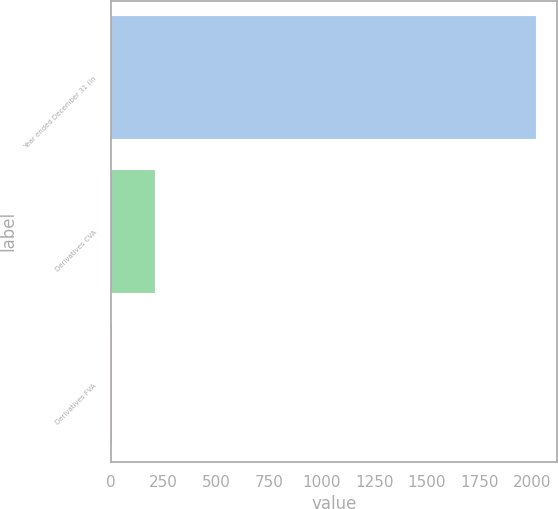Convert chart to OTSL. <chart><loc_0><loc_0><loc_500><loc_500><bar_chart><fcel>Year ended December 31 (in<fcel>Derivatives CVA<fcel>Derivatives FVA<nl><fcel>2016<fcel>207.9<fcel>7<nl></chart> 